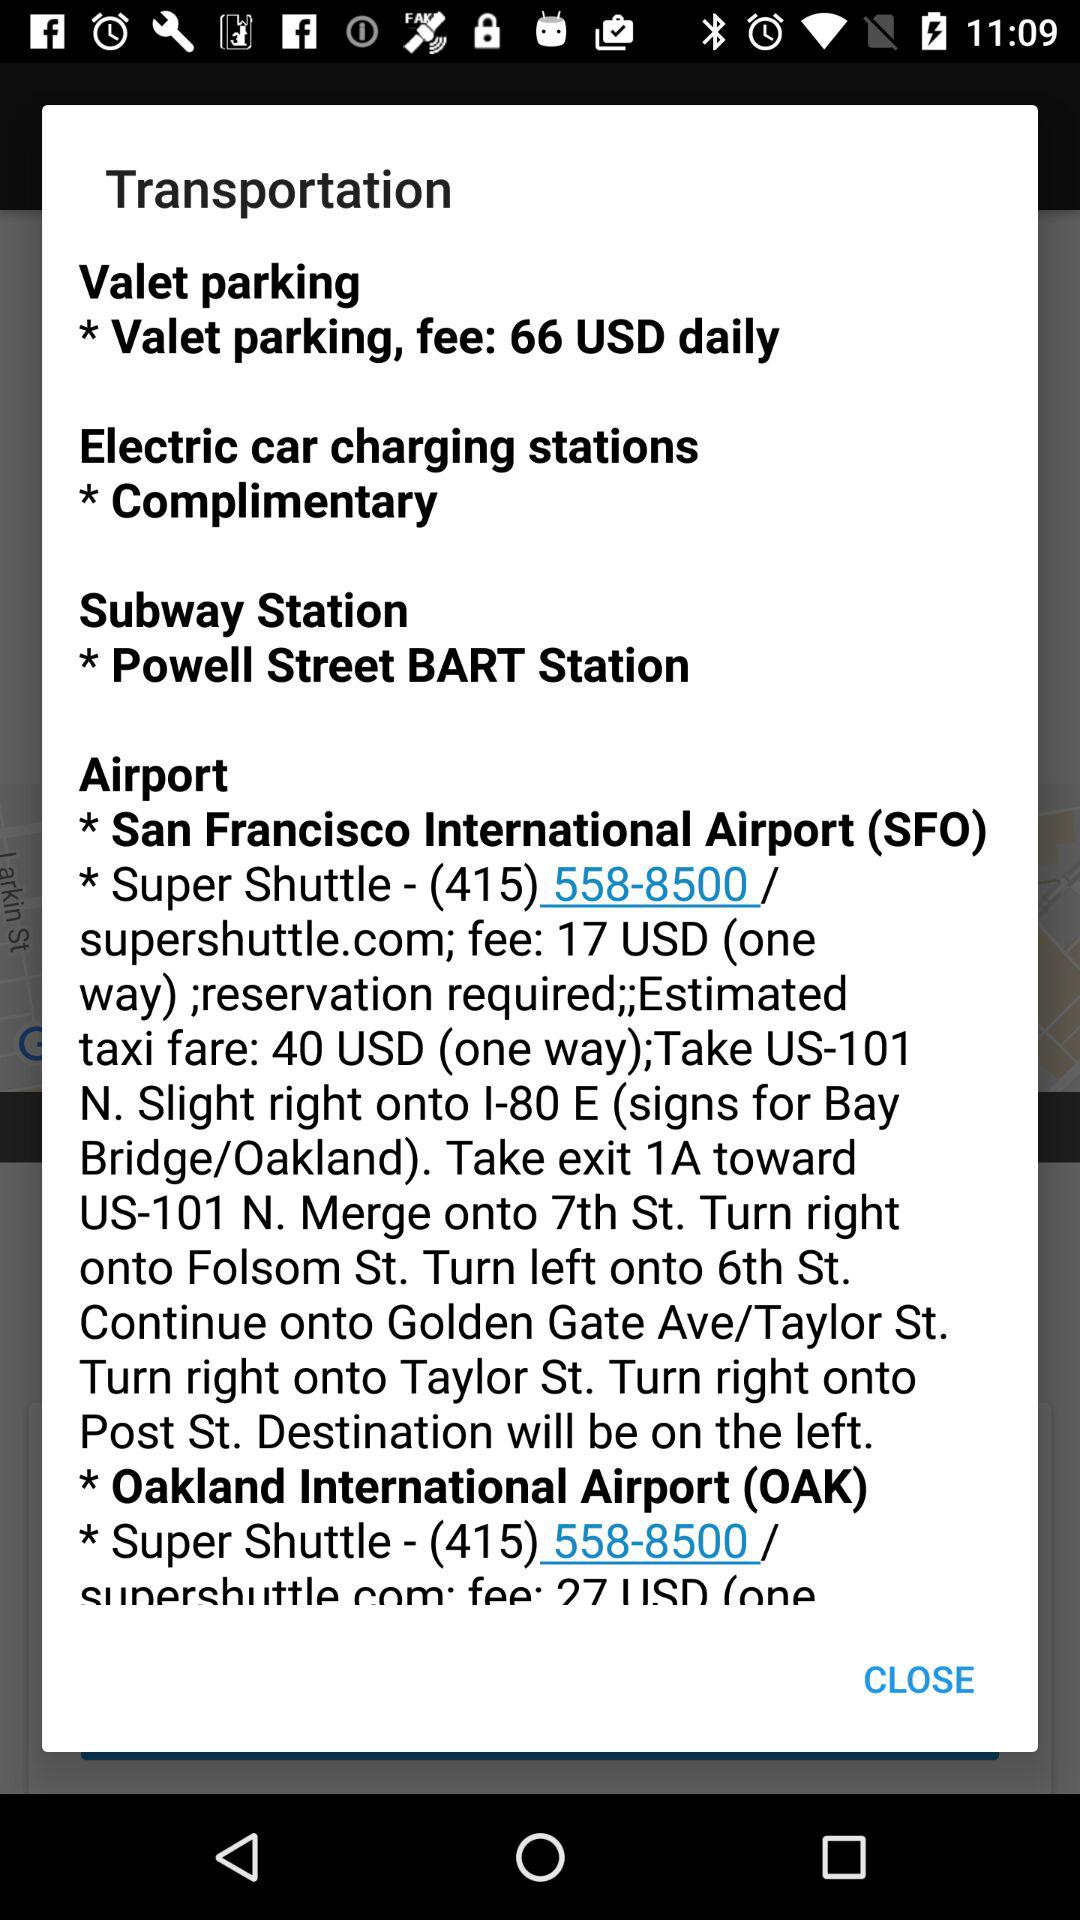What is the one way fee for the shuttle? The fee is 17 USD. 